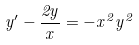<formula> <loc_0><loc_0><loc_500><loc_500>y ^ { \prime } - \frac { 2 y } { x } = - x ^ { 2 } y ^ { 2 }</formula> 